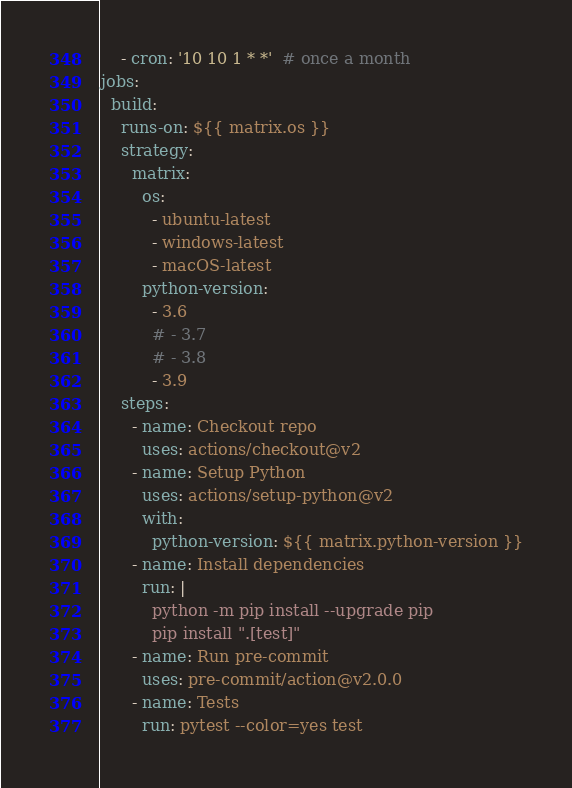<code> <loc_0><loc_0><loc_500><loc_500><_YAML_>    - cron: '10 10 1 * *'  # once a month
jobs:
  build:
    runs-on: ${{ matrix.os }}
    strategy:
      matrix:
        os:
          - ubuntu-latest
          - windows-latest
          - macOS-latest
        python-version:
          - 3.6
          # - 3.7
          # - 3.8
          - 3.9
    steps:
      - name: Checkout repo
        uses: actions/checkout@v2
      - name: Setup Python
        uses: actions/setup-python@v2
        with:
          python-version: ${{ matrix.python-version }}
      - name: Install dependencies
        run: |
          python -m pip install --upgrade pip
          pip install ".[test]"
      - name: Run pre-commit
        uses: pre-commit/action@v2.0.0
      - name: Tests
        run: pytest --color=yes test
</code> 